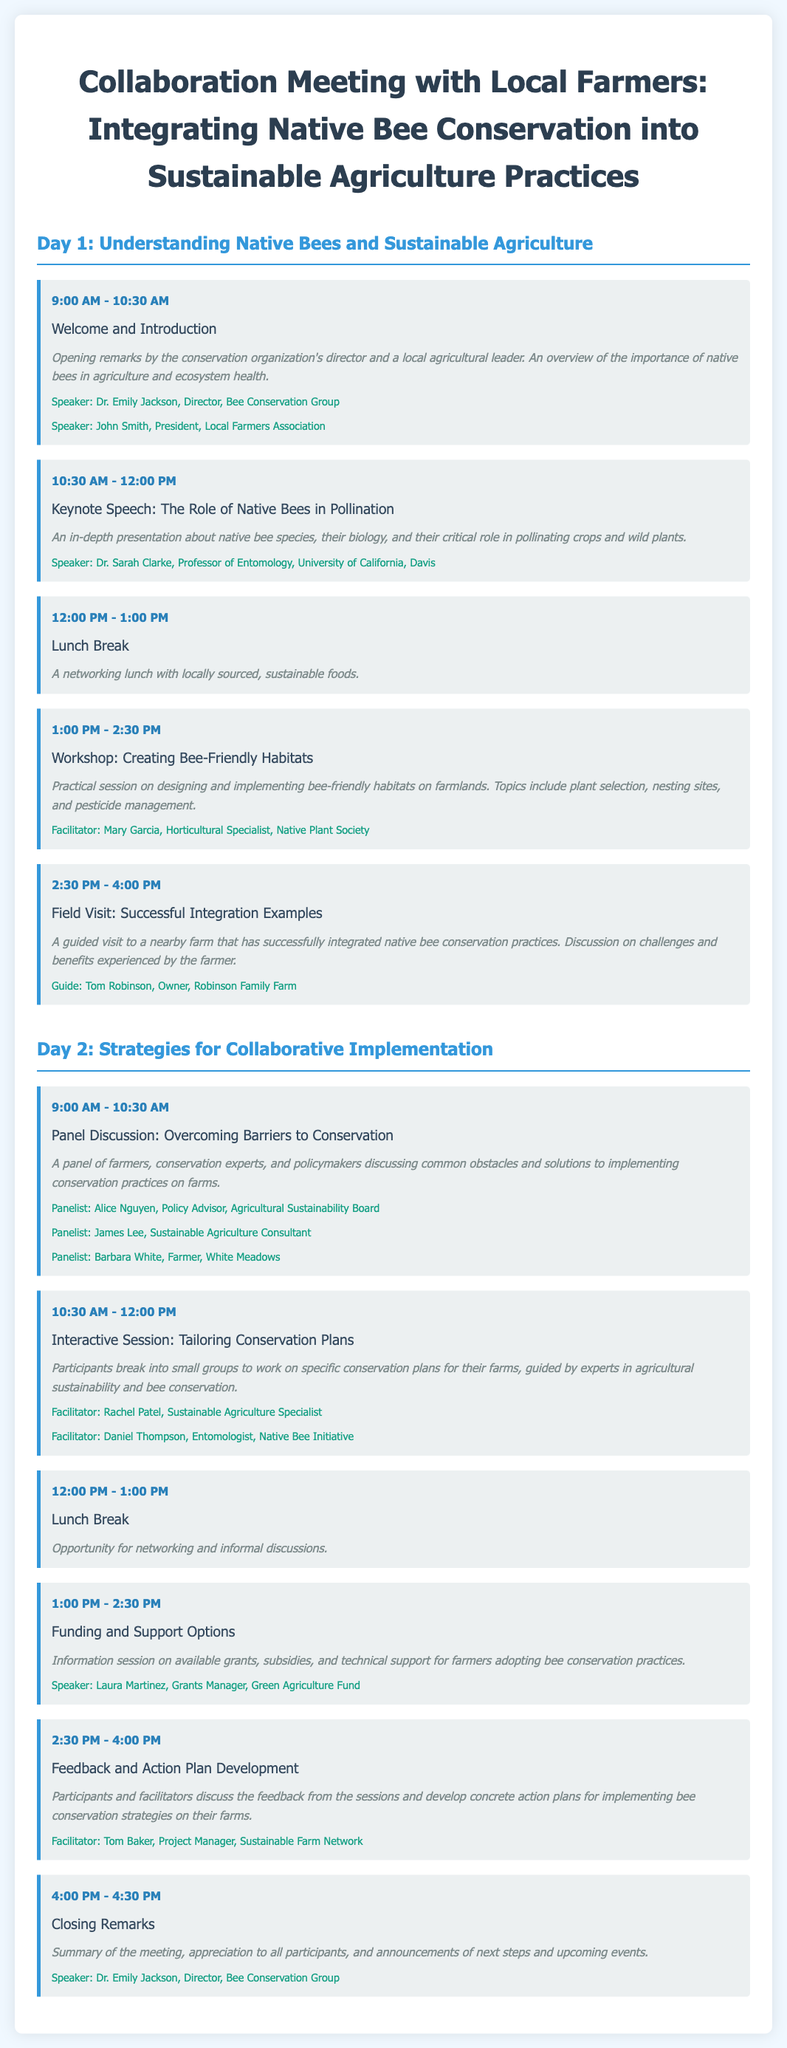what is the title of the meeting? The title of the meeting is specified in the document header and relates to collaboration between local farmers and conservation efforts.
Answer: Collaboration Meeting with Local Farmers: Integrating Native Bee Conservation into Sustainable Agriculture Practices who is the keynote speaker? The keynote speaker is mentioned in the second session of the first day, providing insights on native bees.
Answer: Dr. Sarah Clarke what is the duration of the first session on Day 1? The first session starts at 9:00 AM and ends at 10:30 AM, totaling one and a half hours.
Answer: 1.5 hours what is the focus of the workshop on Day 1? The workshop title indicates it is about designing and implementing habitats beneficial for native bees.
Answer: Creating Bee-Friendly Habitats how many panelists are there in the panel discussion on Day 2? The document lists three individuals participating in the discussion on overcoming barriers.
Answer: 3 which session is facilitated by Mary Garcia? The document specifies the session she facilitates, which focuses on practical applications for farmers.
Answer: Workshop: Creating Bee-Friendly Habitats what is the time for the closing remarks? The closing remarks are scheduled at the end of the meeting, specifically mentioned in the document.
Answer: 4:00 PM - 4:30 PM how many facilitators are there during the interactive session on Day 2? The interactive session lists two facilitators guiding participants in creating conservation plans.
Answer: 2 who is the speaker discussing funding options? The document identifies the speaker providing information on grants and support for farmers.
Answer: Laura Martinez 